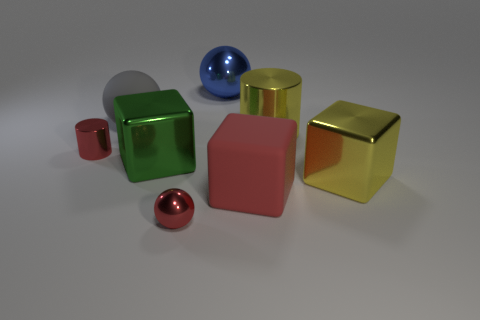Subtract 1 blocks. How many blocks are left? 2 Add 1 tiny red shiny cylinders. How many objects exist? 9 Subtract all cubes. How many objects are left? 5 Add 4 blue things. How many blue things exist? 5 Subtract 0 cyan balls. How many objects are left? 8 Subtract all large blocks. Subtract all large yellow metallic cylinders. How many objects are left? 4 Add 4 large yellow cubes. How many large yellow cubes are left? 5 